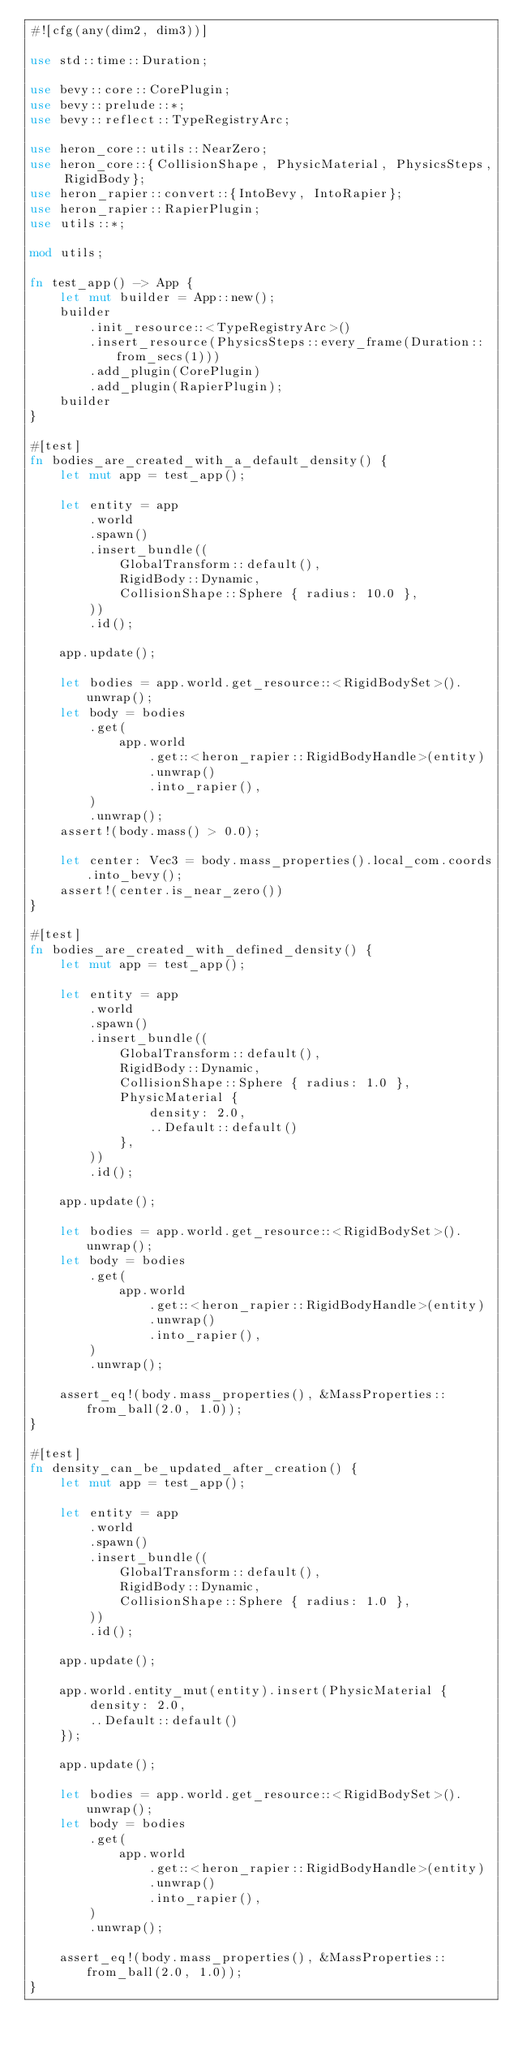Convert code to text. <code><loc_0><loc_0><loc_500><loc_500><_Rust_>#![cfg(any(dim2, dim3))]

use std::time::Duration;

use bevy::core::CorePlugin;
use bevy::prelude::*;
use bevy::reflect::TypeRegistryArc;

use heron_core::utils::NearZero;
use heron_core::{CollisionShape, PhysicMaterial, PhysicsSteps, RigidBody};
use heron_rapier::convert::{IntoBevy, IntoRapier};
use heron_rapier::RapierPlugin;
use utils::*;

mod utils;

fn test_app() -> App {
    let mut builder = App::new();
    builder
        .init_resource::<TypeRegistryArc>()
        .insert_resource(PhysicsSteps::every_frame(Duration::from_secs(1)))
        .add_plugin(CorePlugin)
        .add_plugin(RapierPlugin);
    builder
}

#[test]
fn bodies_are_created_with_a_default_density() {
    let mut app = test_app();

    let entity = app
        .world
        .spawn()
        .insert_bundle((
            GlobalTransform::default(),
            RigidBody::Dynamic,
            CollisionShape::Sphere { radius: 10.0 },
        ))
        .id();

    app.update();

    let bodies = app.world.get_resource::<RigidBodySet>().unwrap();
    let body = bodies
        .get(
            app.world
                .get::<heron_rapier::RigidBodyHandle>(entity)
                .unwrap()
                .into_rapier(),
        )
        .unwrap();
    assert!(body.mass() > 0.0);

    let center: Vec3 = body.mass_properties().local_com.coords.into_bevy();
    assert!(center.is_near_zero())
}

#[test]
fn bodies_are_created_with_defined_density() {
    let mut app = test_app();

    let entity = app
        .world
        .spawn()
        .insert_bundle((
            GlobalTransform::default(),
            RigidBody::Dynamic,
            CollisionShape::Sphere { radius: 1.0 },
            PhysicMaterial {
                density: 2.0,
                ..Default::default()
            },
        ))
        .id();

    app.update();

    let bodies = app.world.get_resource::<RigidBodySet>().unwrap();
    let body = bodies
        .get(
            app.world
                .get::<heron_rapier::RigidBodyHandle>(entity)
                .unwrap()
                .into_rapier(),
        )
        .unwrap();

    assert_eq!(body.mass_properties(), &MassProperties::from_ball(2.0, 1.0));
}

#[test]
fn density_can_be_updated_after_creation() {
    let mut app = test_app();

    let entity = app
        .world
        .spawn()
        .insert_bundle((
            GlobalTransform::default(),
            RigidBody::Dynamic,
            CollisionShape::Sphere { radius: 1.0 },
        ))
        .id();

    app.update();

    app.world.entity_mut(entity).insert(PhysicMaterial {
        density: 2.0,
        ..Default::default()
    });

    app.update();

    let bodies = app.world.get_resource::<RigidBodySet>().unwrap();
    let body = bodies
        .get(
            app.world
                .get::<heron_rapier::RigidBodyHandle>(entity)
                .unwrap()
                .into_rapier(),
        )
        .unwrap();

    assert_eq!(body.mass_properties(), &MassProperties::from_ball(2.0, 1.0));
}
</code> 